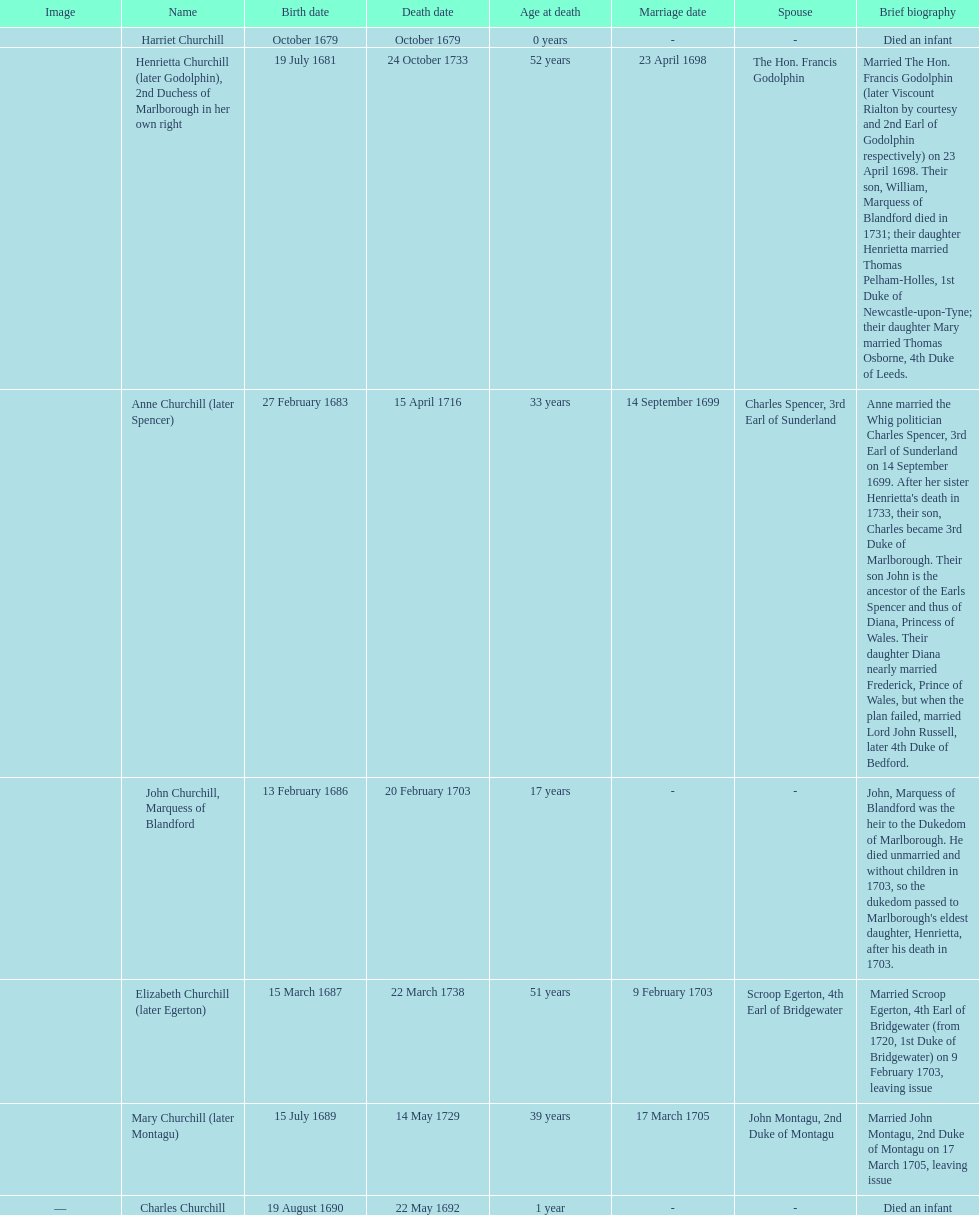Which child was the first to die? Harriet Churchill. 